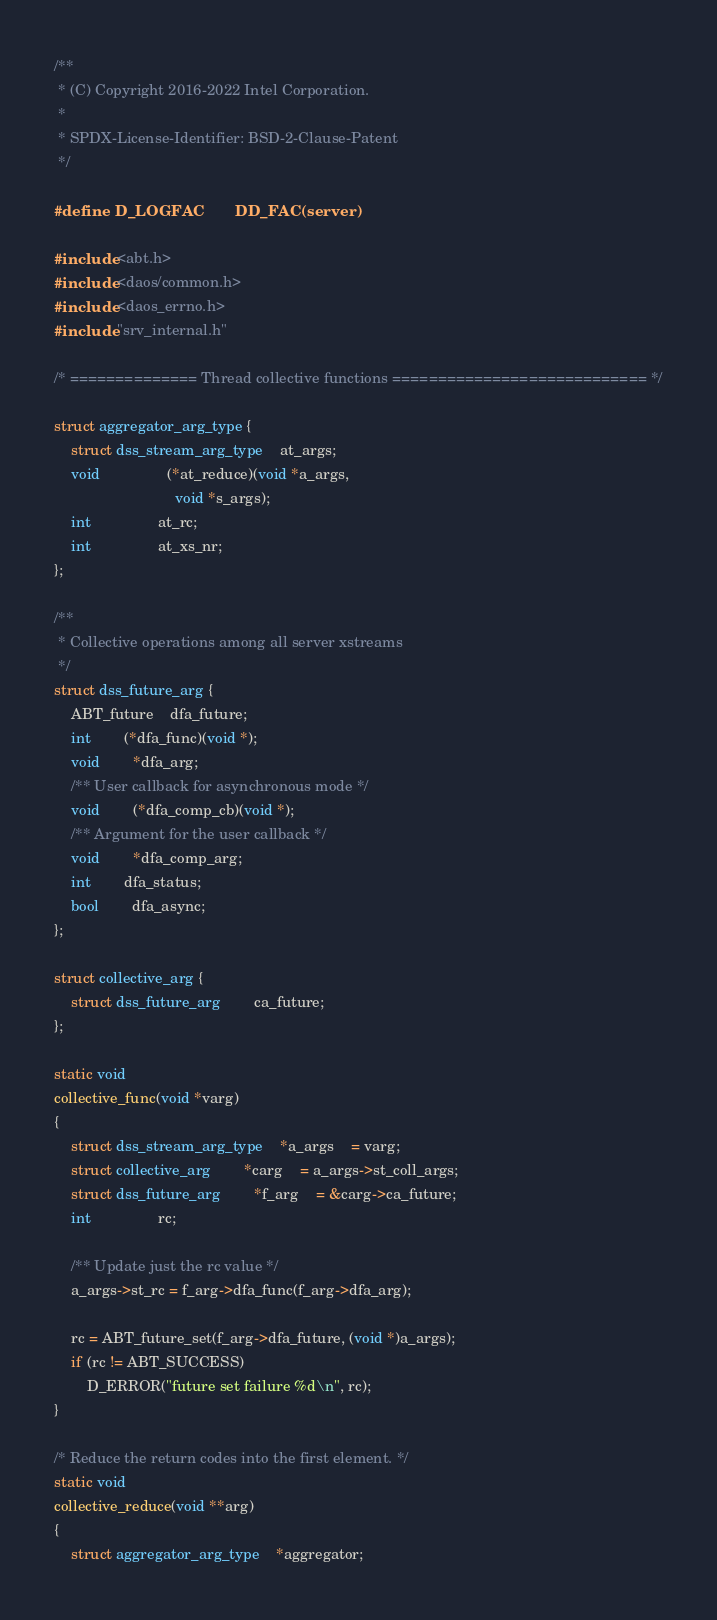Convert code to text. <code><loc_0><loc_0><loc_500><loc_500><_C_>/**
 * (C) Copyright 2016-2022 Intel Corporation.
 *
 * SPDX-License-Identifier: BSD-2-Clause-Patent
 */

#define D_LOGFAC       DD_FAC(server)

#include <abt.h>
#include <daos/common.h>
#include <daos_errno.h>
#include "srv_internal.h"

/* ============== Thread collective functions ============================ */

struct aggregator_arg_type {
	struct dss_stream_arg_type	at_args;
	void				(*at_reduce)(void *a_args,
						     void *s_args);
	int				at_rc;
	int				at_xs_nr;
};

/**
 * Collective operations among all server xstreams
 */
struct dss_future_arg {
	ABT_future	dfa_future;
	int		(*dfa_func)(void *);
	void		*dfa_arg;
	/** User callback for asynchronous mode */
	void		(*dfa_comp_cb)(void *);
	/** Argument for the user callback */
	void		*dfa_comp_arg;
	int		dfa_status;
	bool		dfa_async;
};

struct collective_arg {
	struct dss_future_arg		ca_future;
};

static void
collective_func(void *varg)
{
	struct dss_stream_arg_type	*a_args	= varg;
	struct collective_arg		*carg	= a_args->st_coll_args;
	struct dss_future_arg		*f_arg	= &carg->ca_future;
	int				rc;

	/** Update just the rc value */
	a_args->st_rc = f_arg->dfa_func(f_arg->dfa_arg);

	rc = ABT_future_set(f_arg->dfa_future, (void *)a_args);
	if (rc != ABT_SUCCESS)
		D_ERROR("future set failure %d\n", rc);
}

/* Reduce the return codes into the first element. */
static void
collective_reduce(void **arg)
{
	struct aggregator_arg_type	*aggregator;</code> 